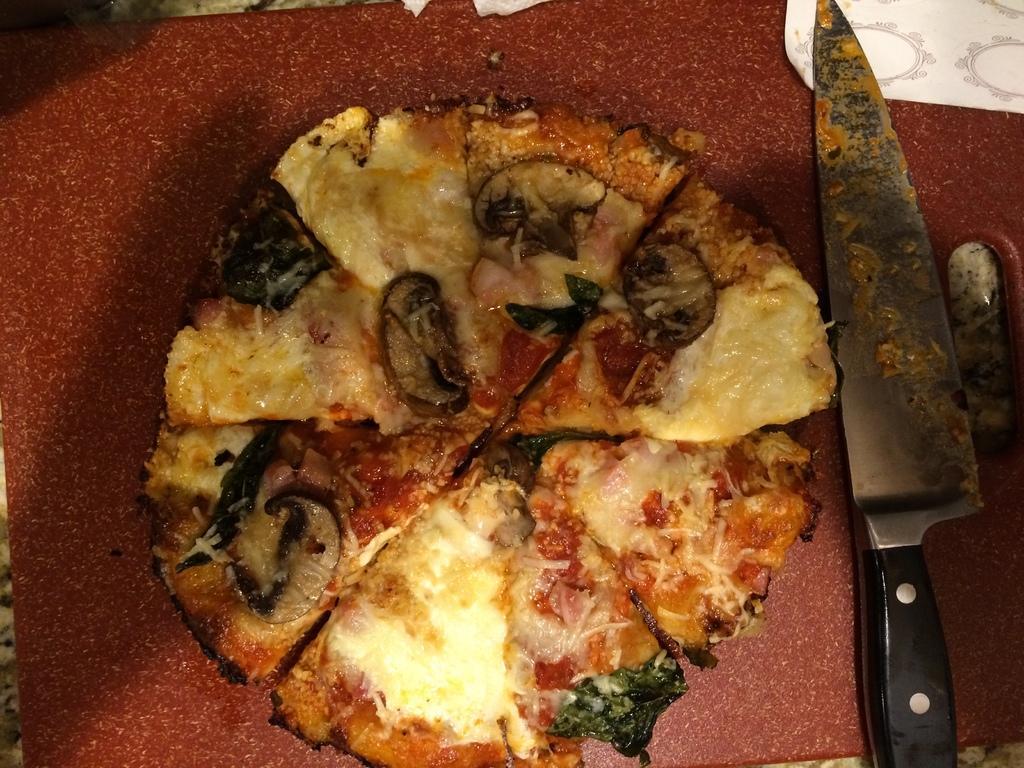Describe this image in one or two sentences. In this image we can see a pizza and a knife on the surface. 